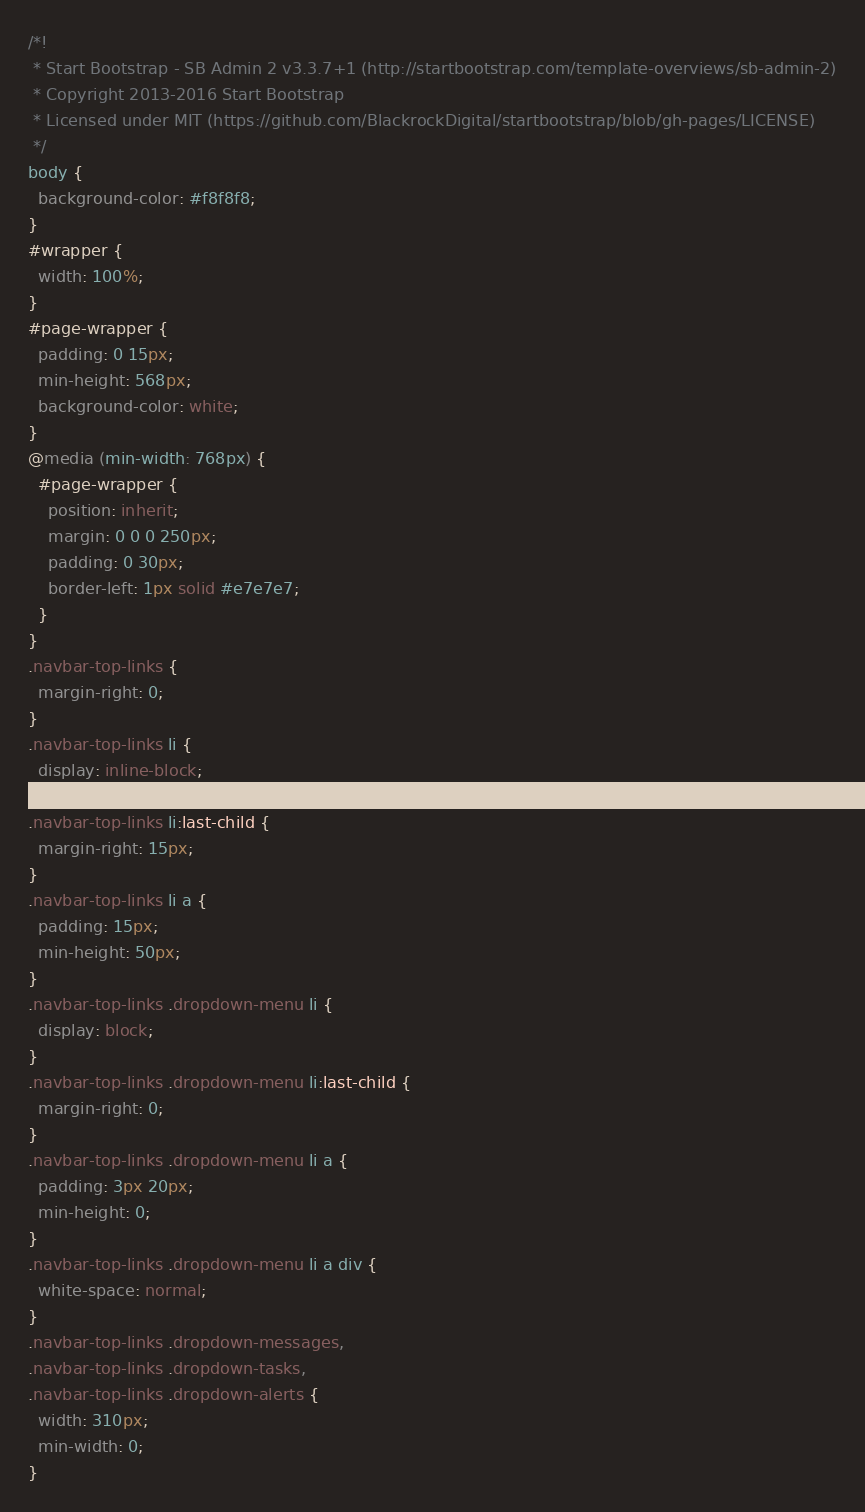Convert code to text. <code><loc_0><loc_0><loc_500><loc_500><_CSS_>/*!
 * Start Bootstrap - SB Admin 2 v3.3.7+1 (http://startbootstrap.com/template-overviews/sb-admin-2)
 * Copyright 2013-2016 Start Bootstrap
 * Licensed under MIT (https://github.com/BlackrockDigital/startbootstrap/blob/gh-pages/LICENSE)
 */
body {
  background-color: #f8f8f8;
}
#wrapper {
  width: 100%;
}
#page-wrapper {
  padding: 0 15px;
  min-height: 568px;
  background-color: white;
}
@media (min-width: 768px) {
  #page-wrapper {
    position: inherit;
    margin: 0 0 0 250px;
    padding: 0 30px;
    border-left: 1px solid #e7e7e7;
  }
}
.navbar-top-links {
  margin-right: 0;
}
.navbar-top-links li {
  display: inline-block;
}
.navbar-top-links li:last-child {
  margin-right: 15px;
}
.navbar-top-links li a {
  padding: 15px;
  min-height: 50px;
}
.navbar-top-links .dropdown-menu li {
  display: block;
}
.navbar-top-links .dropdown-menu li:last-child {
  margin-right: 0;
}
.navbar-top-links .dropdown-menu li a {
  padding: 3px 20px;
  min-height: 0;
}
.navbar-top-links .dropdown-menu li a div {
  white-space: normal;
}
.navbar-top-links .dropdown-messages,
.navbar-top-links .dropdown-tasks,
.navbar-top-links .dropdown-alerts {
  width: 310px;
  min-width: 0;
}</code> 